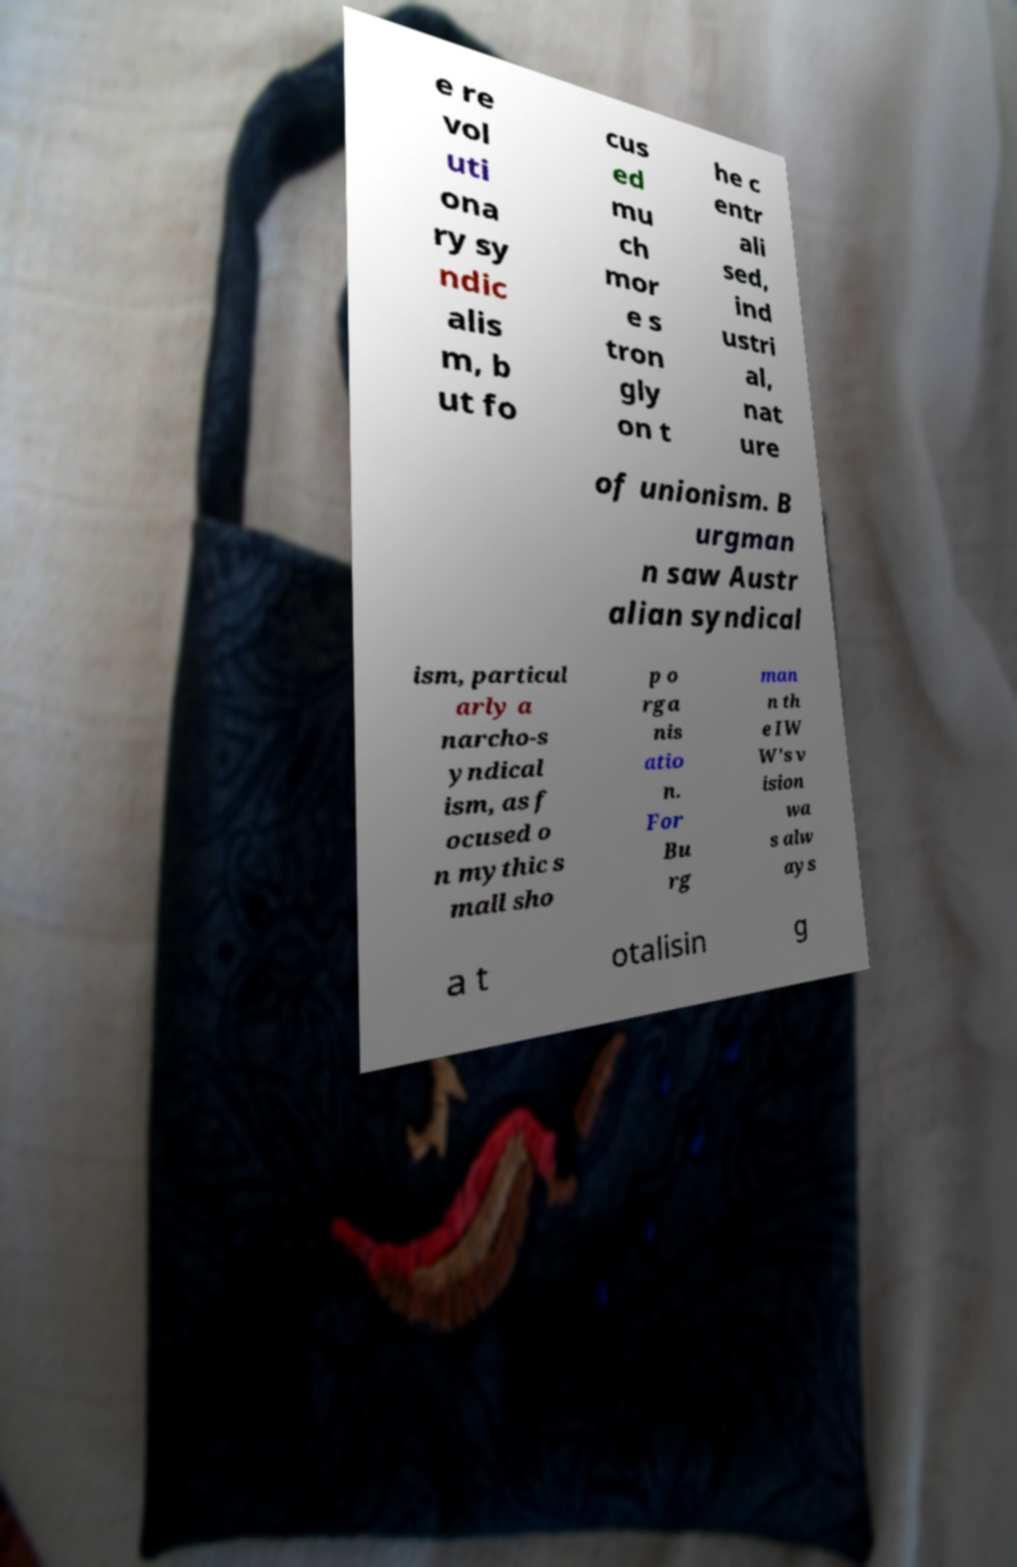What messages or text are displayed in this image? I need them in a readable, typed format. e re vol uti ona ry sy ndic alis m, b ut fo cus ed mu ch mor e s tron gly on t he c entr ali sed, ind ustri al, nat ure of unionism. B urgman n saw Austr alian syndical ism, particul arly a narcho-s yndical ism, as f ocused o n mythic s mall sho p o rga nis atio n. For Bu rg man n th e IW W's v ision wa s alw ays a t otalisin g 